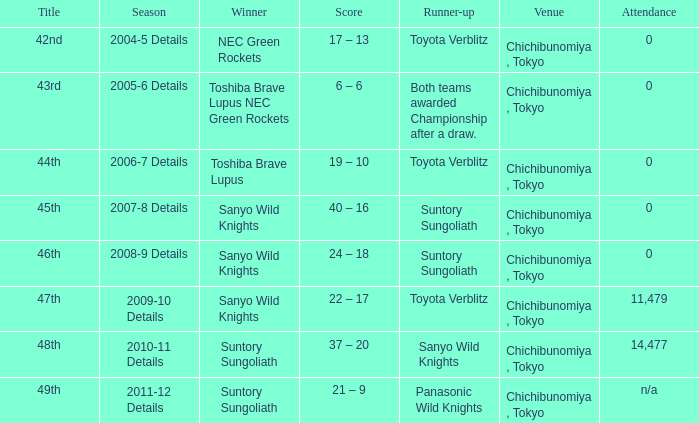What is the result when the champion was sanyo wild knights, and a runner-up of suntory sungoliath? 40 – 16, 24 – 18. 